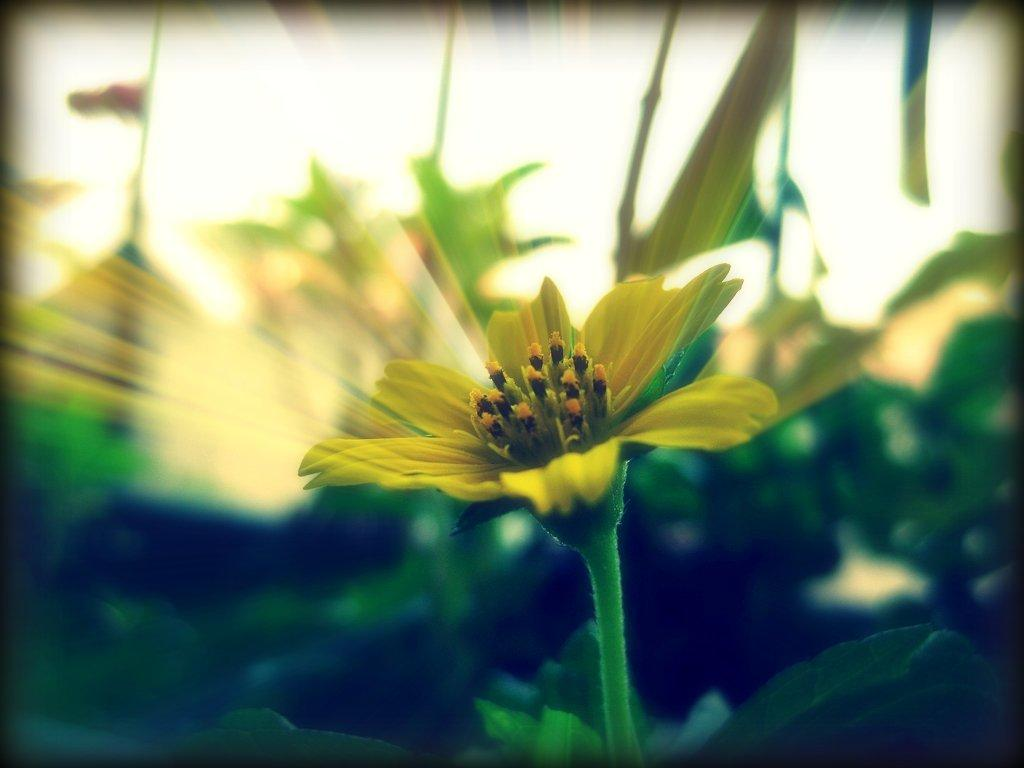What type of plants can be seen in the image? There are flowering plants in the image. What part of the natural environment is visible in the image? The sky is visible in the image. Where might this image have been taken, considering the presence of flowering plants? The image may have been taken in a garden, as flowering plants are commonly found in gardens. What riddle can be solved by looking at the image? There is no riddle present in the image, as it simply depicts flowering plants and the sky. 